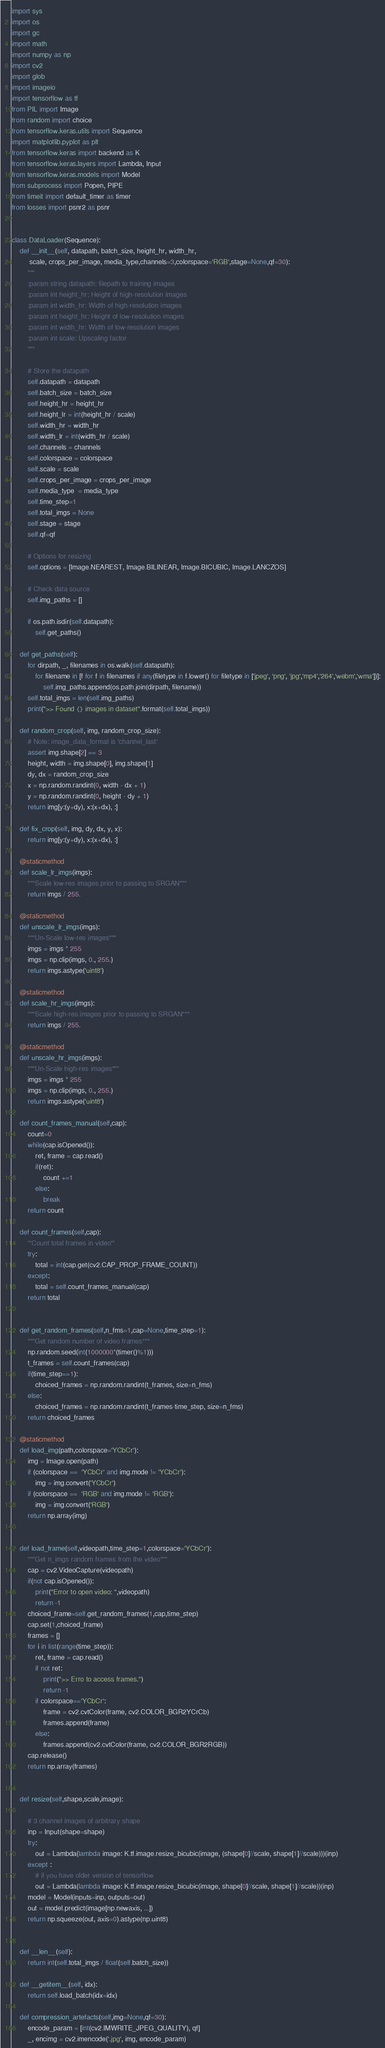Convert code to text. <code><loc_0><loc_0><loc_500><loc_500><_Python_>import sys  
import os
import gc
import math
import numpy as np
import cv2
import glob
import imageio
import tensorflow as tf
from PIL import Image
from random import choice
from tensorflow.keras.utils import Sequence
import matplotlib.pyplot as plt
from tensorflow.keras import backend as K
from tensorflow.keras.layers import Lambda, Input
from tensorflow.keras.models import Model
from subprocess import Popen, PIPE
from timeit import default_timer as timer
from losses import psnr2 as psnr


class DataLoader(Sequence):
    def __init__(self, datapath, batch_size, height_hr, width_hr, 
         scale, crops_per_image, media_type,channels=3,colorspace='RGB',stage=None,qf=30):
        """        
        :param string datapath: filepath to training images
        :param int height_hr: Height of high-resolution images
        :param int width_hr: Width of high-resolution images
        :param int height_hr: Height of low-resolution images
        :param int width_hr: Width of low-resolution images
        :param int scale: Upscaling factor
        """

        # Store the datapath
        self.datapath = datapath
        self.batch_size = batch_size
        self.height_hr = height_hr
        self.height_lr = int(height_hr / scale)
        self.width_hr = width_hr
        self.width_lr = int(width_hr / scale)
        self.channels = channels
        self.colorspace = colorspace
        self.scale = scale
        self.crops_per_image = crops_per_image
        self.media_type  = media_type
        self.time_step=1
        self.total_imgs = None
        self.stage = stage
        self.qf=qf
        
        # Options for resizing
        self.options = [Image.NEAREST, Image.BILINEAR, Image.BICUBIC, Image.LANCZOS]
        
        # Check data source
        self.img_paths = []

        if os.path.isdir(self.datapath):
            self.get_paths()
    
    def get_paths(self):
        for dirpath, _, filenames in os.walk(self.datapath):
            for filename in [f for f in filenames if any(filetype in f.lower() for filetype in ['jpeg', 'png', 'jpg','mp4','264','webm','wma'])]:
                self.img_paths.append(os.path.join(dirpath, filename))
        self.total_imgs = len(self.img_paths)
        print(">> Found {} images in dataset".format(self.total_imgs))
    
    def random_crop(self, img, random_crop_size):
        # Note: image_data_format is 'channel_last'
        assert img.shape[2] == 3
        height, width = img.shape[0], img.shape[1]
        dy, dx = random_crop_size
        x = np.random.randint(0, width - dx + 1)
        y = np.random.randint(0, height - dy + 1)
        return img[y:(y+dy), x:(x+dx), :]

    def fix_crop(self, img, dy, dx, y, x):
        return img[y:(y+dy), x:(x+dx), :]

    @staticmethod
    def scale_lr_imgs(imgs):
        """Scale low-res images prior to passing to SRGAN"""
        return imgs / 255.
    
    @staticmethod
    def unscale_lr_imgs(imgs):
        """Un-Scale low-res images"""
        imgs = imgs * 255
        imgs = np.clip(imgs, 0., 255.)
        return imgs.astype('uint8')
    
    @staticmethod
    def scale_hr_imgs(imgs):
        """Scale high-res images prior to passing to SRGAN"""
        return imgs / 255.
    
    @staticmethod
    def unscale_hr_imgs(imgs):
        """Un-Scale high-res images"""
        imgs = imgs * 255
        imgs = np.clip(imgs, 0., 255.)
        return imgs.astype('uint8')
    
    def count_frames_manual(self,cap):
        count=0
        while(cap.isOpened()):
            ret, frame = cap.read()
            if(ret):
                count +=1
            else:
                break
        return count
    
    def count_frames(self,cap):
        '''Count total frames in video'''
        try:
            total = int(cap.get(cv2.CAP_PROP_FRAME_COUNT))
        except:
            total = self.count_frames_manual(cap)
        return total


    def get_random_frames(self,n_fms=1,cap=None,time_step=1):
        """Get random number of video frames"""
        np.random.seed(int(1000000*(timer()%1)))
        t_frames = self.count_frames(cap)
        if(time_step==1):
            choiced_frames = np.random.randint(t_frames, size=n_fms)
        else:
            choiced_frames = np.random.randint(t_frames-time_step, size=n_fms)
        return choiced_frames
    
    @staticmethod
    def load_img(path,colorspace='YCbCr'):
        img = Image.open(path)
        if (colorspace ==  'YCbCr' and img.mode != 'YCbCr'):
            img = img.convert('YCbCr') 
        if (colorspace ==  'RGB' and img.mode != 'RGB'):
            img = img.convert('RGB')     
        return np.array(img)


    def load_frame(self,videopath,time_step=1,colorspace='YCbCr'):
        """Get n_imgs random frames from the video"""
        cap = cv2.VideoCapture(videopath)
        if(not cap.isOpened()):
            print("Error to open video: ",videopath)
            return -1 
        choiced_frame=self.get_random_frames(1,cap,time_step)
        cap.set(1,choiced_frame)
        frames = []
        for i in list(range(time_step)):
            ret, frame = cap.read()
            if not ret:
                print(">> Erro to access frames.")
                return -1
            if colorspace=='YCbCr':
                frame = cv2.cvtColor(frame, cv2.COLOR_BGR2YCrCb)
                frames.append(frame)
            else:
                frames.append(cv2.cvtColor(frame, cv2.COLOR_BGR2RGB)) 
        cap.release()
        return np.array(frames)    


    def resize(self,shape,scale,image):
    
        # 3 channel images of arbitrary shape
        inp = Input(shape=shape)
        try:
            out = Lambda(lambda image: K.tf.image.resize_bicubic(image, (shape[0]//scale, shape[1]//scale)))(inp)
        except :
            # if you have older version of tensorflow
            out = Lambda(lambda image: K.tf.image.resize_bicubic(image, shape[0]//scale, shape[1]//scale))(inp)
        model = Model(inputs=inp, outputs=out)
        out = model.predict(image[np.newaxis, ...])
        return np.squeeze(out, axis=0).astype(np.uint8) 
   
    
    def __len__(self):
        return int(self.total_imgs / float(self.batch_size))
    
    def __getitem__(self, idx):
        return self.load_batch(idx=idx)   

    def compression_artefacts(self,img=None,qf=30):
        encode_param = [int(cv2.IMWRITE_JPEG_QUALITY), qf]
        _, encimg = cv2.imencode('.jpg', img, encode_param)</code> 